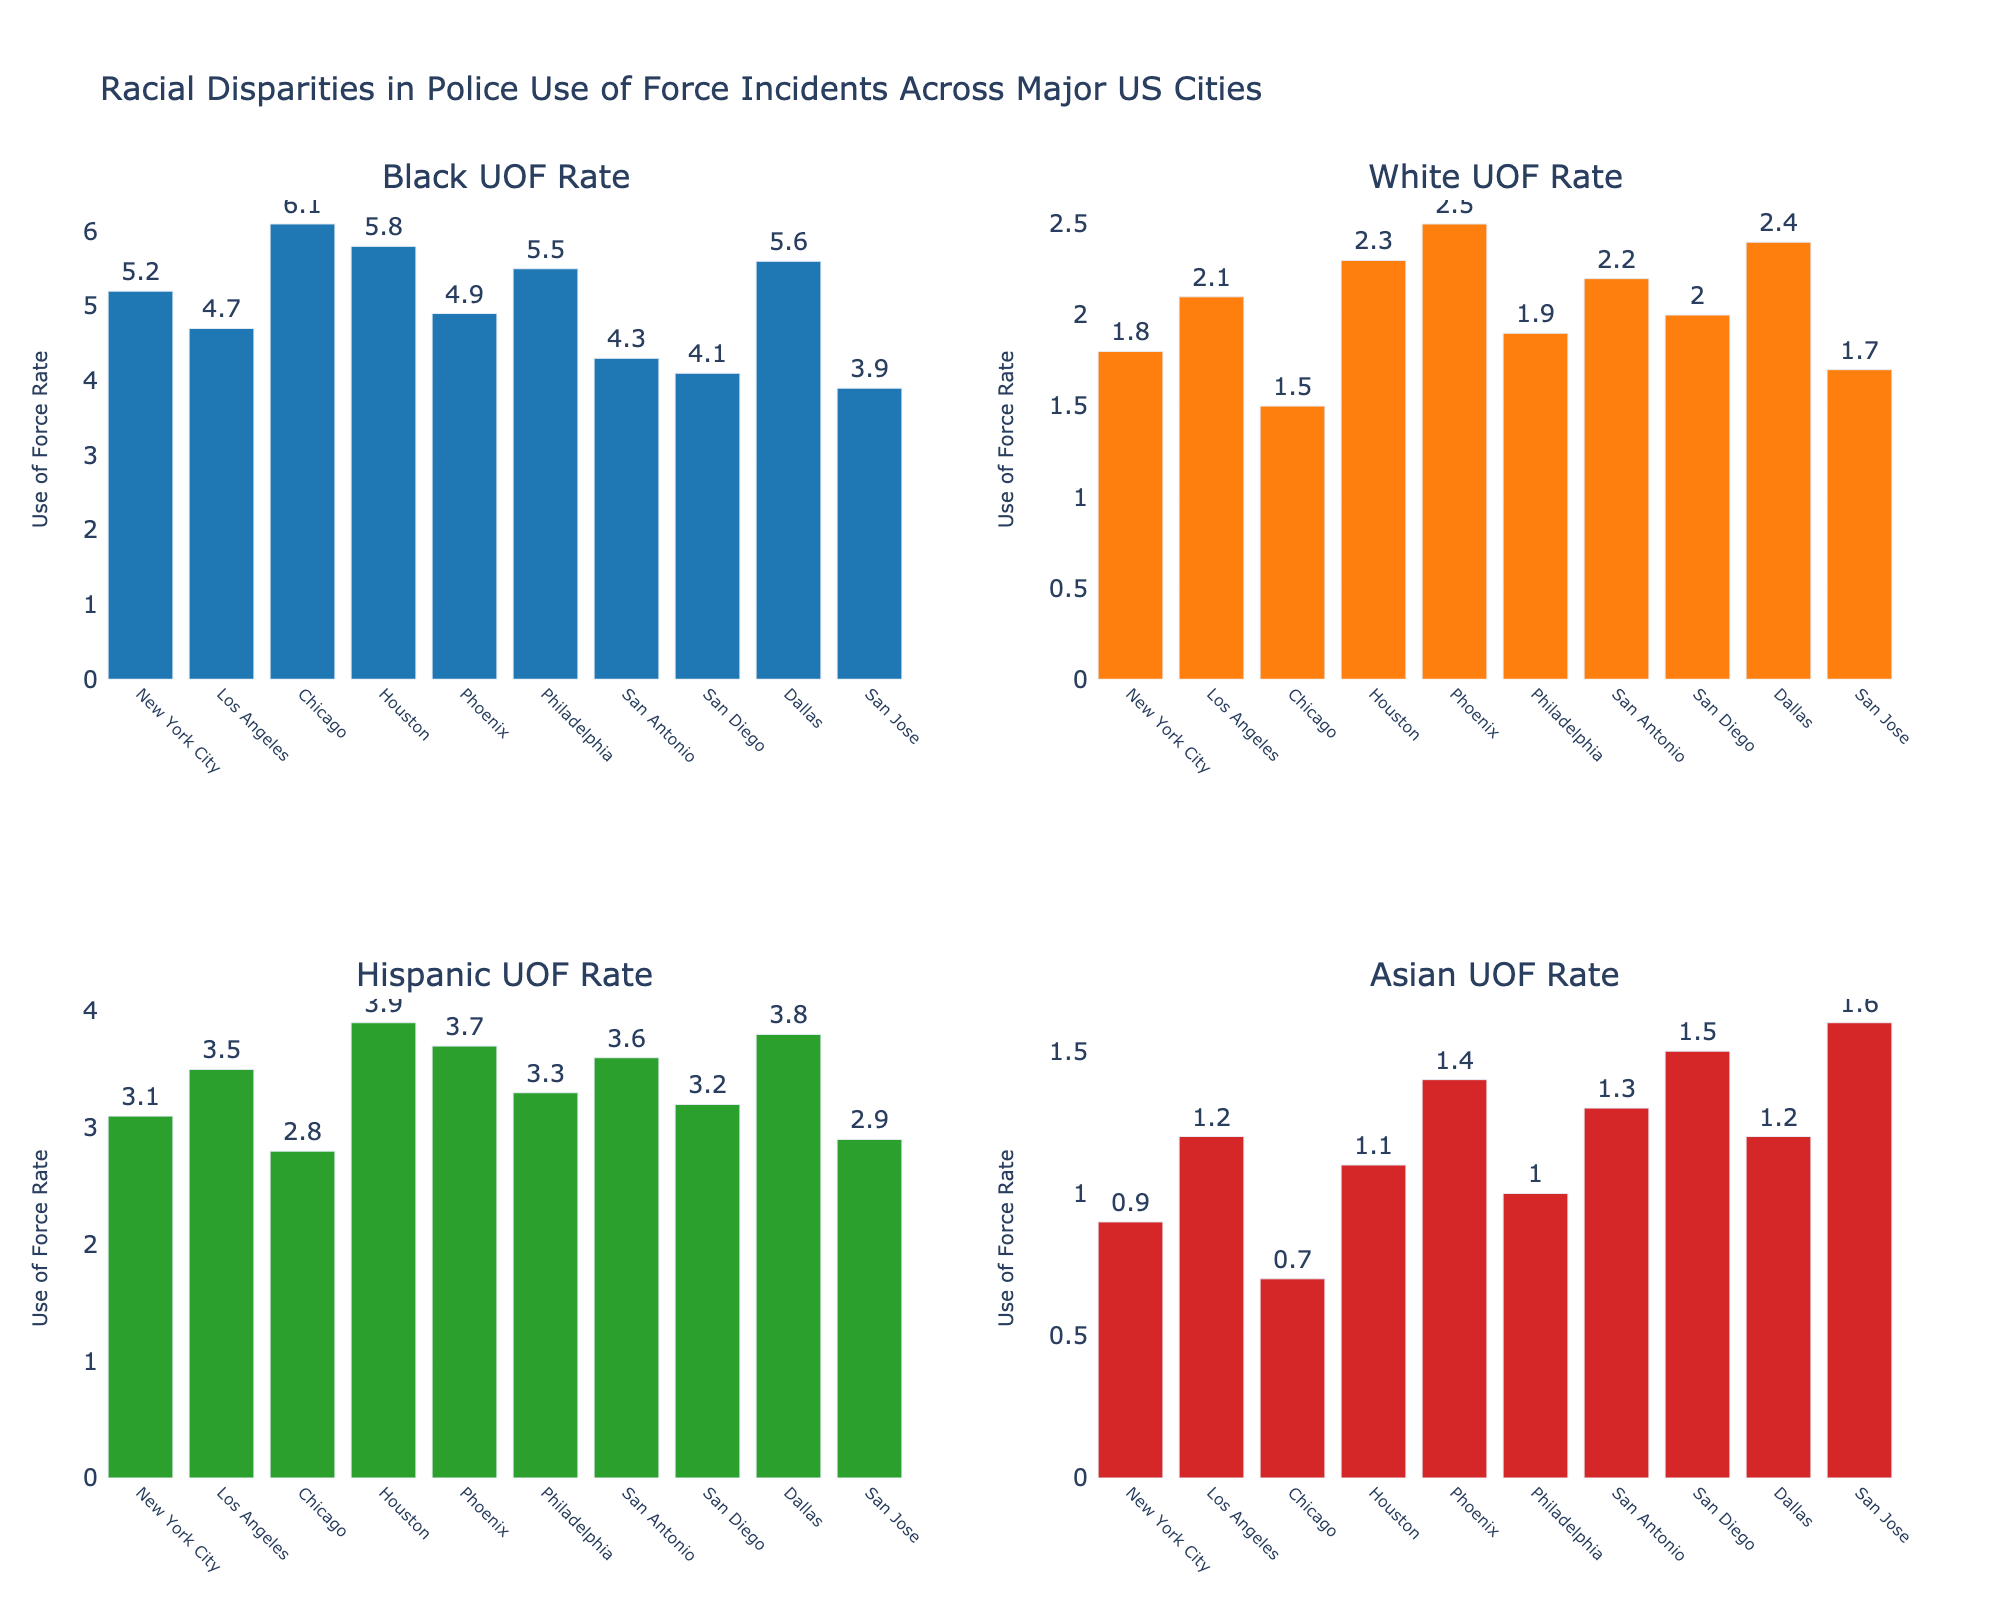what's the title of the figure? The title of the figure is written at the top center of the plot. It gives a summary of what the entire figure represents. The title reads "Racial Disparities in Police Use of Force Incidents Across Major US Cities."
Answer: Racial Disparities in Police Use of Force Incidents Across Major US Cities how many cities are represented in the figure? The x-axes of each subplot list the cities represented in the figure. All four subplots share the same x-axis labels with the names of the cities. By counting them, we see that there are 10 cities.
Answer: 10 which city has the highest Use of Force (UOF) rate for Black individuals? Look at the first subplot titled "Black UOF Rate" and identify the tallest bar. The tallest bar corresponds to Chicago with a value of 6.1.
Answer: Chicago what is the difference in the Use of Force rate between Black and White individuals in Houston? In the subplots for Black UOF Rate and White UOF Rate, find Houston and subtract the White UOF Rate from the Black UOF Rate. The values are 5.8 for Black and 2.3 for White, so the difference is 5.8 - 2.3.
Answer: 3.5 what is the average Asian UOF rate across all cities? Sum the Asian UOF rates of all cities and divide by the number of cities. Adding 0.9 + 1.2 + 0.7 + 1.1 + 1.4 + 1.0 + 1.3 + 1.5 + 1.2 + 1.6 equals 11.9. Dividing 11.9 by 10 gives 1.19.
Answer: 1.19 which racial group has the lowest UOF rates in San Diego? Examine each subplot's bar corresponding to San Diego. The UOF rates are 4.1 (Black), 2.0 (White), 3.2 (Hispanic), and 1.5 (Asian). The lowest rate is for the Asian group at 1.5.
Answer: Asian in which city does the Hispanic UOF rate exceed that of the Black UOF rate? Compare the values in the Black UOF Rate and Hispanic UOF Rate subplots for each city. No city has a higher Hispanic UOF rate compared to the Black UOF rate. Thus, the Hispanic UOF rate does not exceed the Black UOF rate in any city.
Answer: None between Los Angeles and New York City, which city has a higher White UOF rate? Look at the second subplot titled "White UOF Rate" and compare the bars for Los Angeles and New York City. The UOF rates are 2.1 for Los Angeles and 1.8 for New York City. Los Angeles has the higher rate.
Answer: Los Angeles 